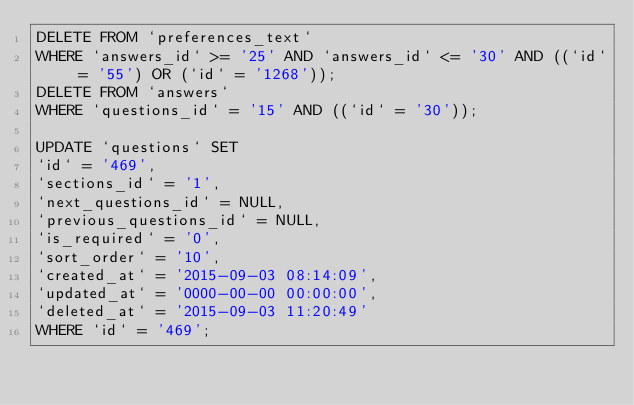<code> <loc_0><loc_0><loc_500><loc_500><_SQL_>DELETE FROM `preferences_text`
WHERE `answers_id` >= '25' AND `answers_id` <= '30' AND ((`id` = '55') OR (`id` = '1268'));
DELETE FROM `answers`
WHERE `questions_id` = '15' AND ((`id` = '30'));

UPDATE `questions` SET
`id` = '469',
`sections_id` = '1',
`next_questions_id` = NULL,
`previous_questions_id` = NULL,
`is_required` = '0',
`sort_order` = '10',
`created_at` = '2015-09-03 08:14:09',
`updated_at` = '0000-00-00 00:00:00',
`deleted_at` = '2015-09-03 11:20:49'
WHERE `id` = '469';
</code> 